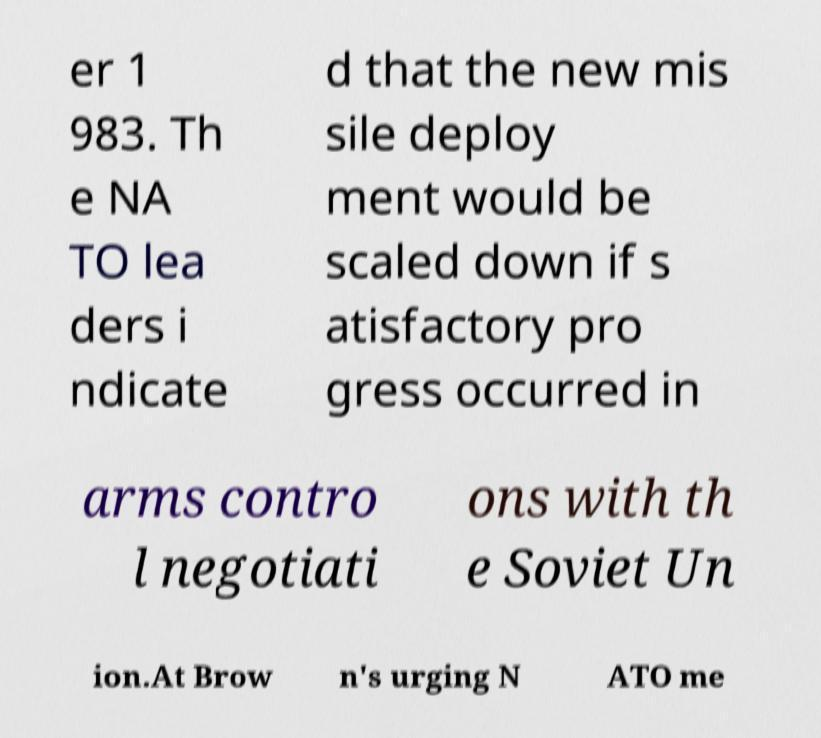For documentation purposes, I need the text within this image transcribed. Could you provide that? er 1 983. Th e NA TO lea ders i ndicate d that the new mis sile deploy ment would be scaled down if s atisfactory pro gress occurred in arms contro l negotiati ons with th e Soviet Un ion.At Brow n's urging N ATO me 